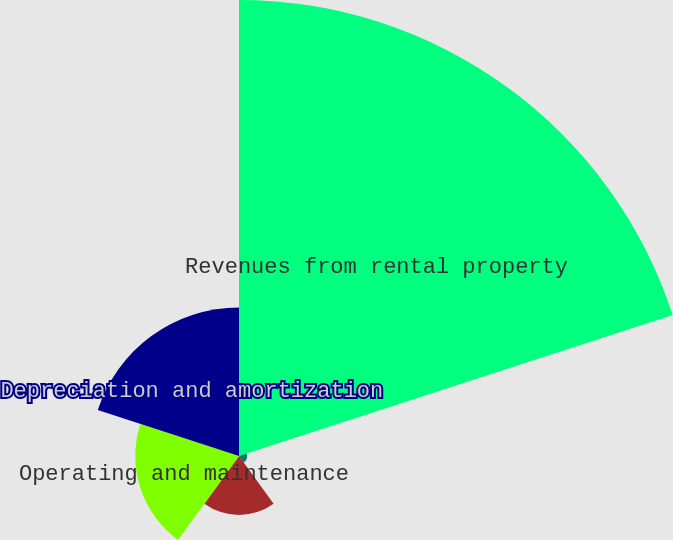Convert chart. <chart><loc_0><loc_0><loc_500><loc_500><pie_chart><fcel>Revenues from rental property<fcel>Rent<fcel>Real estate taxes<fcel>Operating and maintenance<fcel>Depreciation and amortization<nl><fcel>58.83%<fcel>1.04%<fcel>7.6%<fcel>13.38%<fcel>19.16%<nl></chart> 